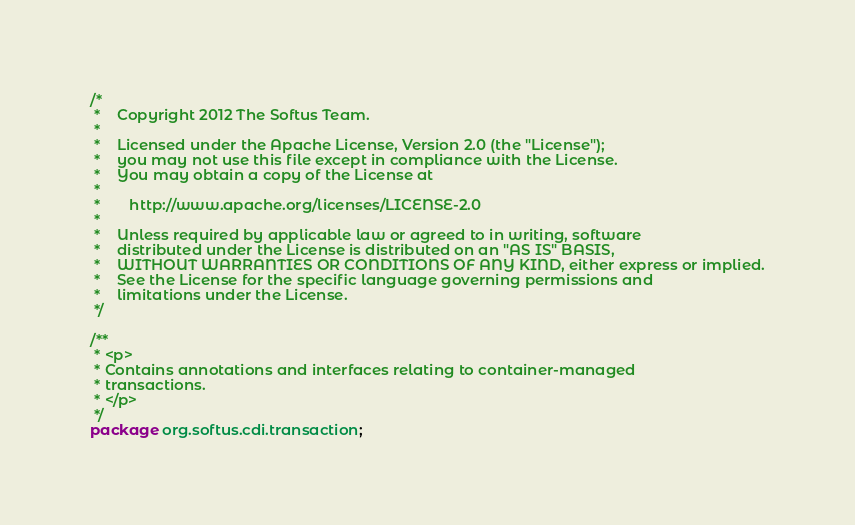Convert code to text. <code><loc_0><loc_0><loc_500><loc_500><_Java_>/*
 *    Copyright 2012 The Softus Team.
 *
 *    Licensed under the Apache License, Version 2.0 (the "License");
 *    you may not use this file except in compliance with the License.
 *    You may obtain a copy of the License at
 *
 *       http://www.apache.org/licenses/LICENSE-2.0
 *
 *    Unless required by applicable law or agreed to in writing, software
 *    distributed under the License is distributed on an "AS IS" BASIS,
 *    WITHOUT WARRANTIES OR CONDITIONS OF ANY KIND, either express or implied.
 *    See the License for the specific language governing permissions and
 *    limitations under the License.
 */

/**
 * <p>
 * Contains annotations and interfaces relating to container-managed
 * transactions.
 * </p>
 */
package org.softus.cdi.transaction;
</code> 